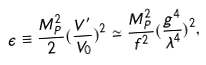Convert formula to latex. <formula><loc_0><loc_0><loc_500><loc_500>\epsilon \equiv \frac { M _ { P } ^ { 2 } } { 2 } ( \frac { V ^ { \prime } } { V _ { 0 } } ) ^ { 2 } \simeq \frac { M _ { P } ^ { 2 } } { f ^ { 2 } } ( \frac { g ^ { 4 } } { \lambda ^ { 4 } } ) ^ { 2 } ,</formula> 